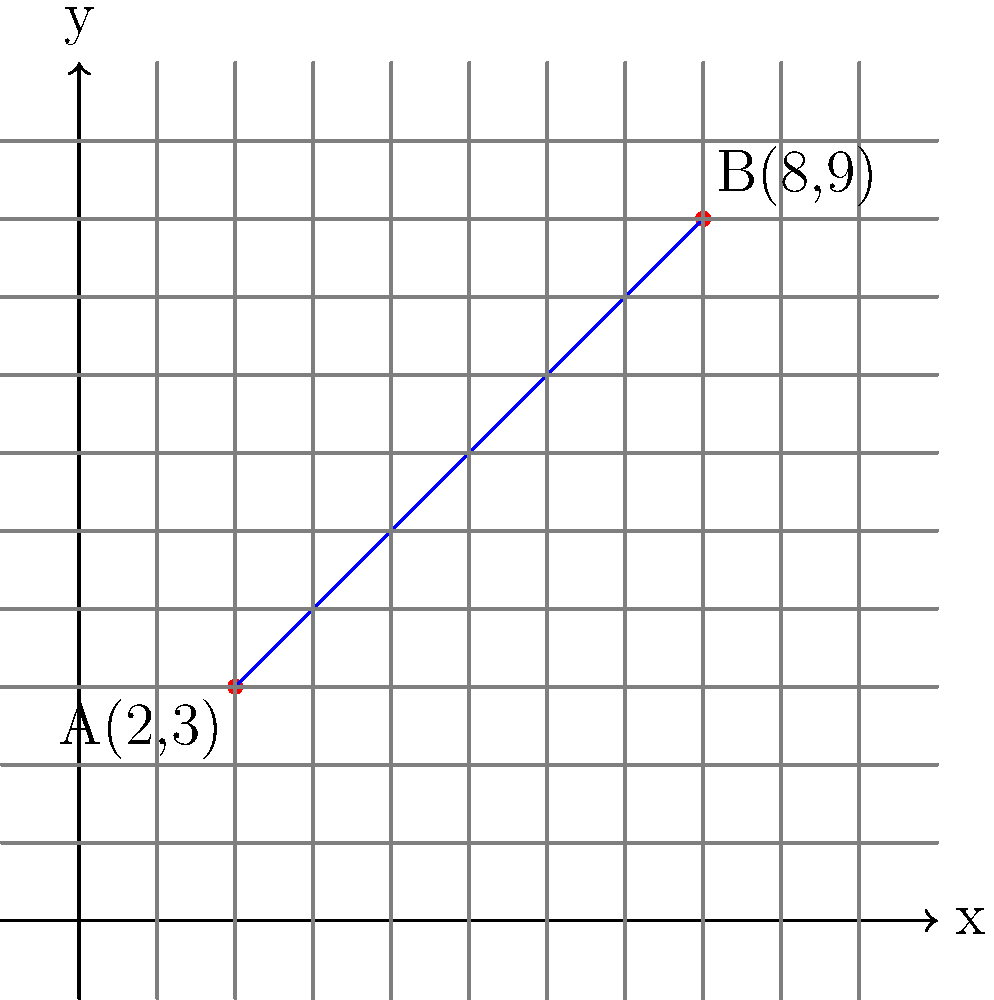As a technology executive transitioning into professional speaking, you often use visual aids to explain complex concepts. In a presentation about data trends, you need to determine the equation of a line passing through two data points: A(2,3) and B(8,9). What is the slope-intercept form of this line? To find the equation of the line in slope-intercept form $(y = mx + b)$, we need to follow these steps:

1. Calculate the slope $(m)$ using the two given points:
   $m = \frac{y_2 - y_1}{x_2 - x_1} = \frac{9 - 3}{8 - 2} = \frac{6}{6} = 1$

2. Use the point-slope form of a line $(y - y_1 = m(x - x_1))$ with either point. Let's use A(2,3):
   $y - 3 = 1(x - 2)$

3. Expand the equation:
   $y - 3 = x - 2$

4. Solve for $y$ to get the slope-intercept form:
   $y = x - 2 + 3$
   $y = x + 1$

Therefore, the slope-intercept form of the line passing through A(2,3) and B(8,9) is $y = x + 1$.
Answer: $y = x + 1$ 